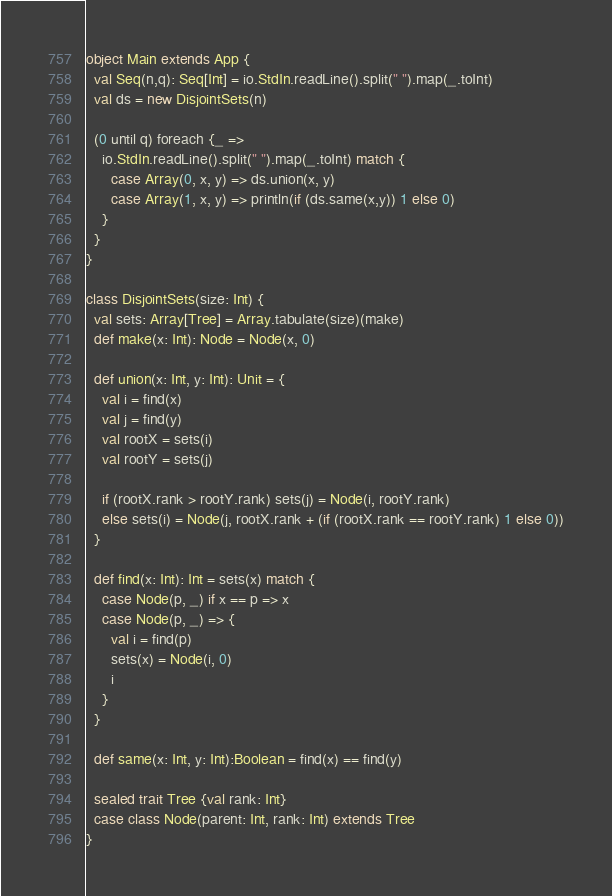Convert code to text. <code><loc_0><loc_0><loc_500><loc_500><_Scala_>object Main extends App {
  val Seq(n,q): Seq[Int] = io.StdIn.readLine().split(" ").map(_.toInt)
  val ds = new DisjointSets(n)

  (0 until q) foreach {_ =>
    io.StdIn.readLine().split(" ").map(_.toInt) match {
      case Array(0, x, y) => ds.union(x, y)
      case Array(1, x, y) => println(if (ds.same(x,y)) 1 else 0)
    }
  }
}

class DisjointSets(size: Int) {
  val sets: Array[Tree] = Array.tabulate(size)(make)
  def make(x: Int): Node = Node(x, 0)

  def union(x: Int, y: Int): Unit = {
    val i = find(x)
    val j = find(y)
    val rootX = sets(i)
    val rootY = sets(j)

    if (rootX.rank > rootY.rank) sets(j) = Node(i, rootY.rank)
    else sets(i) = Node(j, rootX.rank + (if (rootX.rank == rootY.rank) 1 else 0))
  }

  def find(x: Int): Int = sets(x) match {
    case Node(p, _) if x == p => x
    case Node(p, _) => {
      val i = find(p)
      sets(x) = Node(i, 0)
      i
    }
  }

  def same(x: Int, y: Int):Boolean = find(x) == find(y)

  sealed trait Tree {val rank: Int}
  case class Node(parent: Int, rank: Int) extends Tree
}</code> 